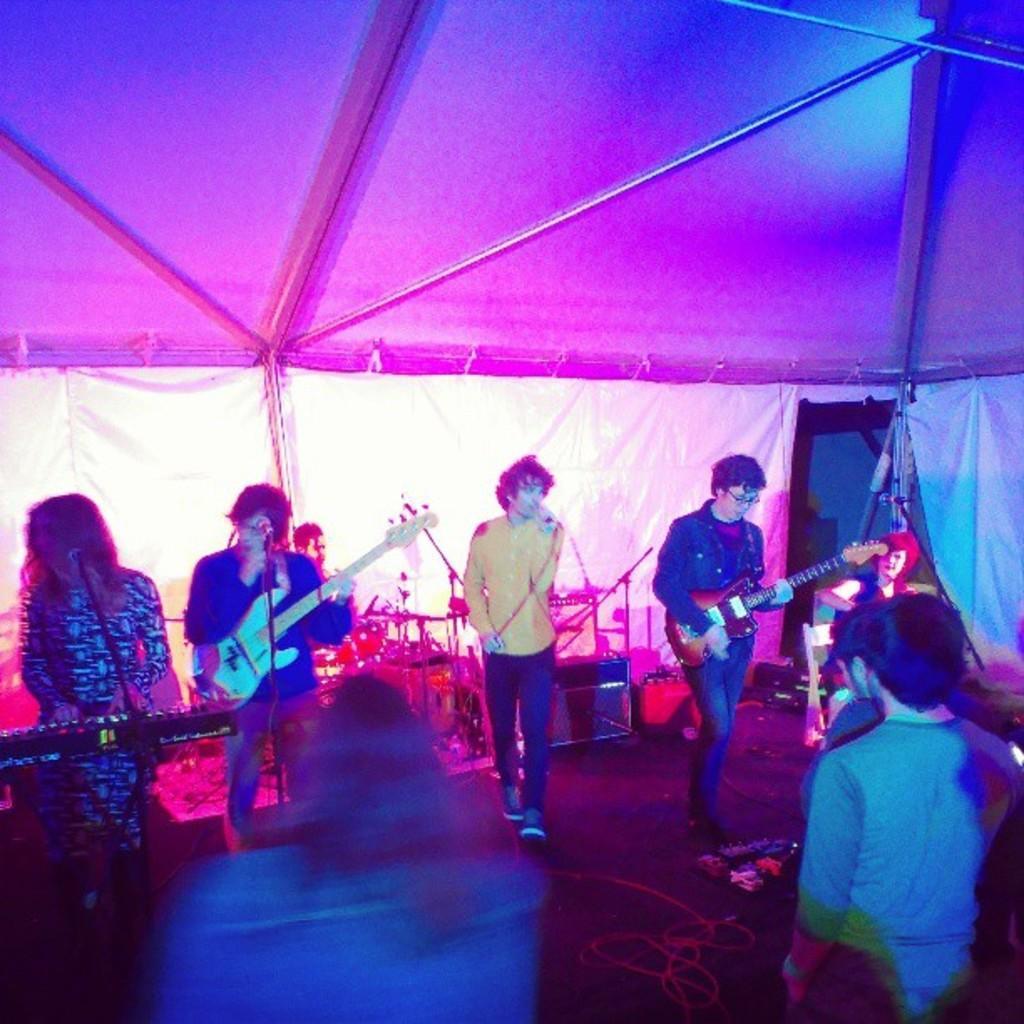Could you give a brief overview of what you see in this image? In this picture there are three boys, they are singing on the stage, the boy who is right side of the image is playing the guitar and the boy who is left side of the image is also playing the guitar and the girl is left side of the image is playing xylophone and there are audience in front of the boys and there is a boy who is sitting behind the stage is playing tabla. 